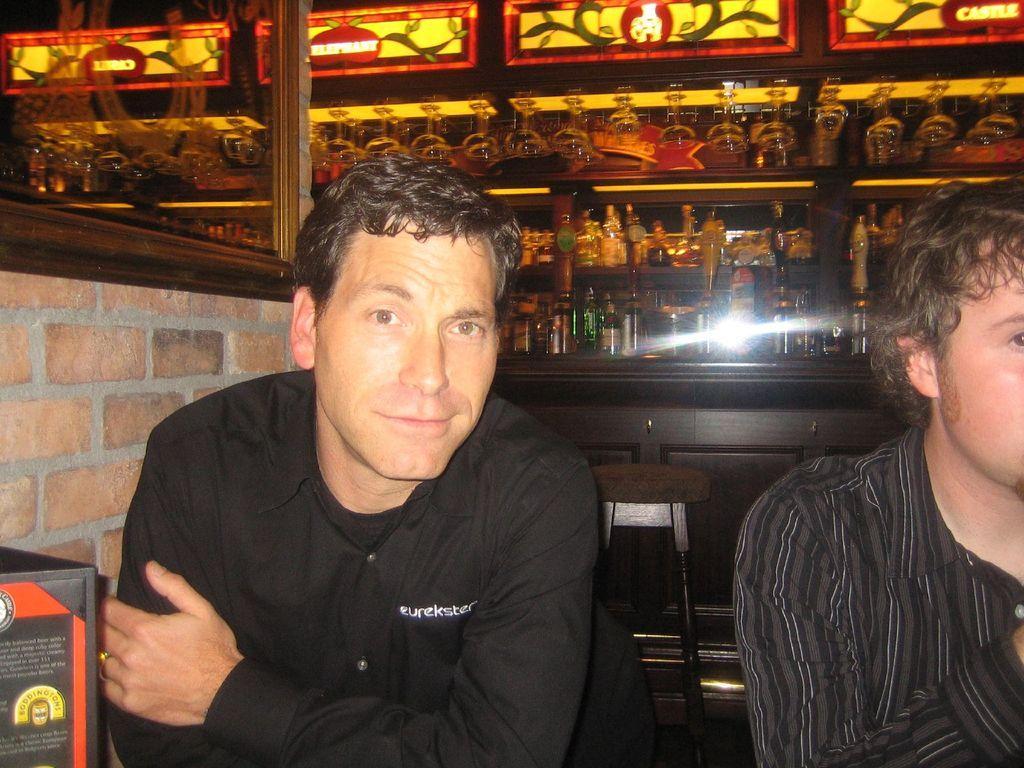How would you summarize this image in a sentence or two? There is one person sitting on the chair is wearing black color shirt, and there is one other person sitting on the right side to him. There is a wall in the background. We can see there are some bottles are kept in a shelf at the top of this image. There is one object at the bottom left corner of this image. 